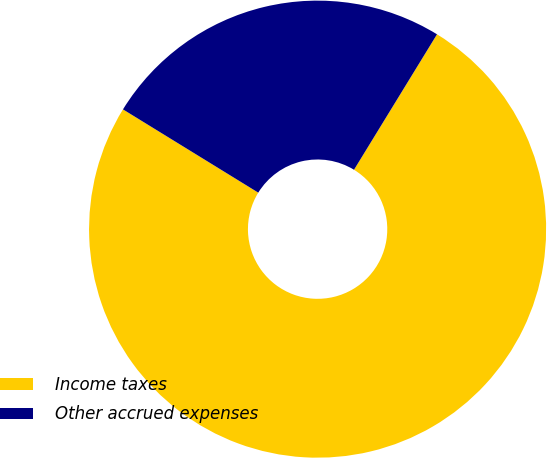Convert chart. <chart><loc_0><loc_0><loc_500><loc_500><pie_chart><fcel>Income taxes<fcel>Other accrued expenses<nl><fcel>75.03%<fcel>24.97%<nl></chart> 